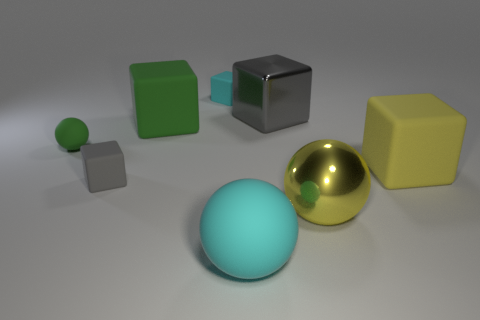There is a small matte object to the right of the large green matte block; what color is it? cyan 